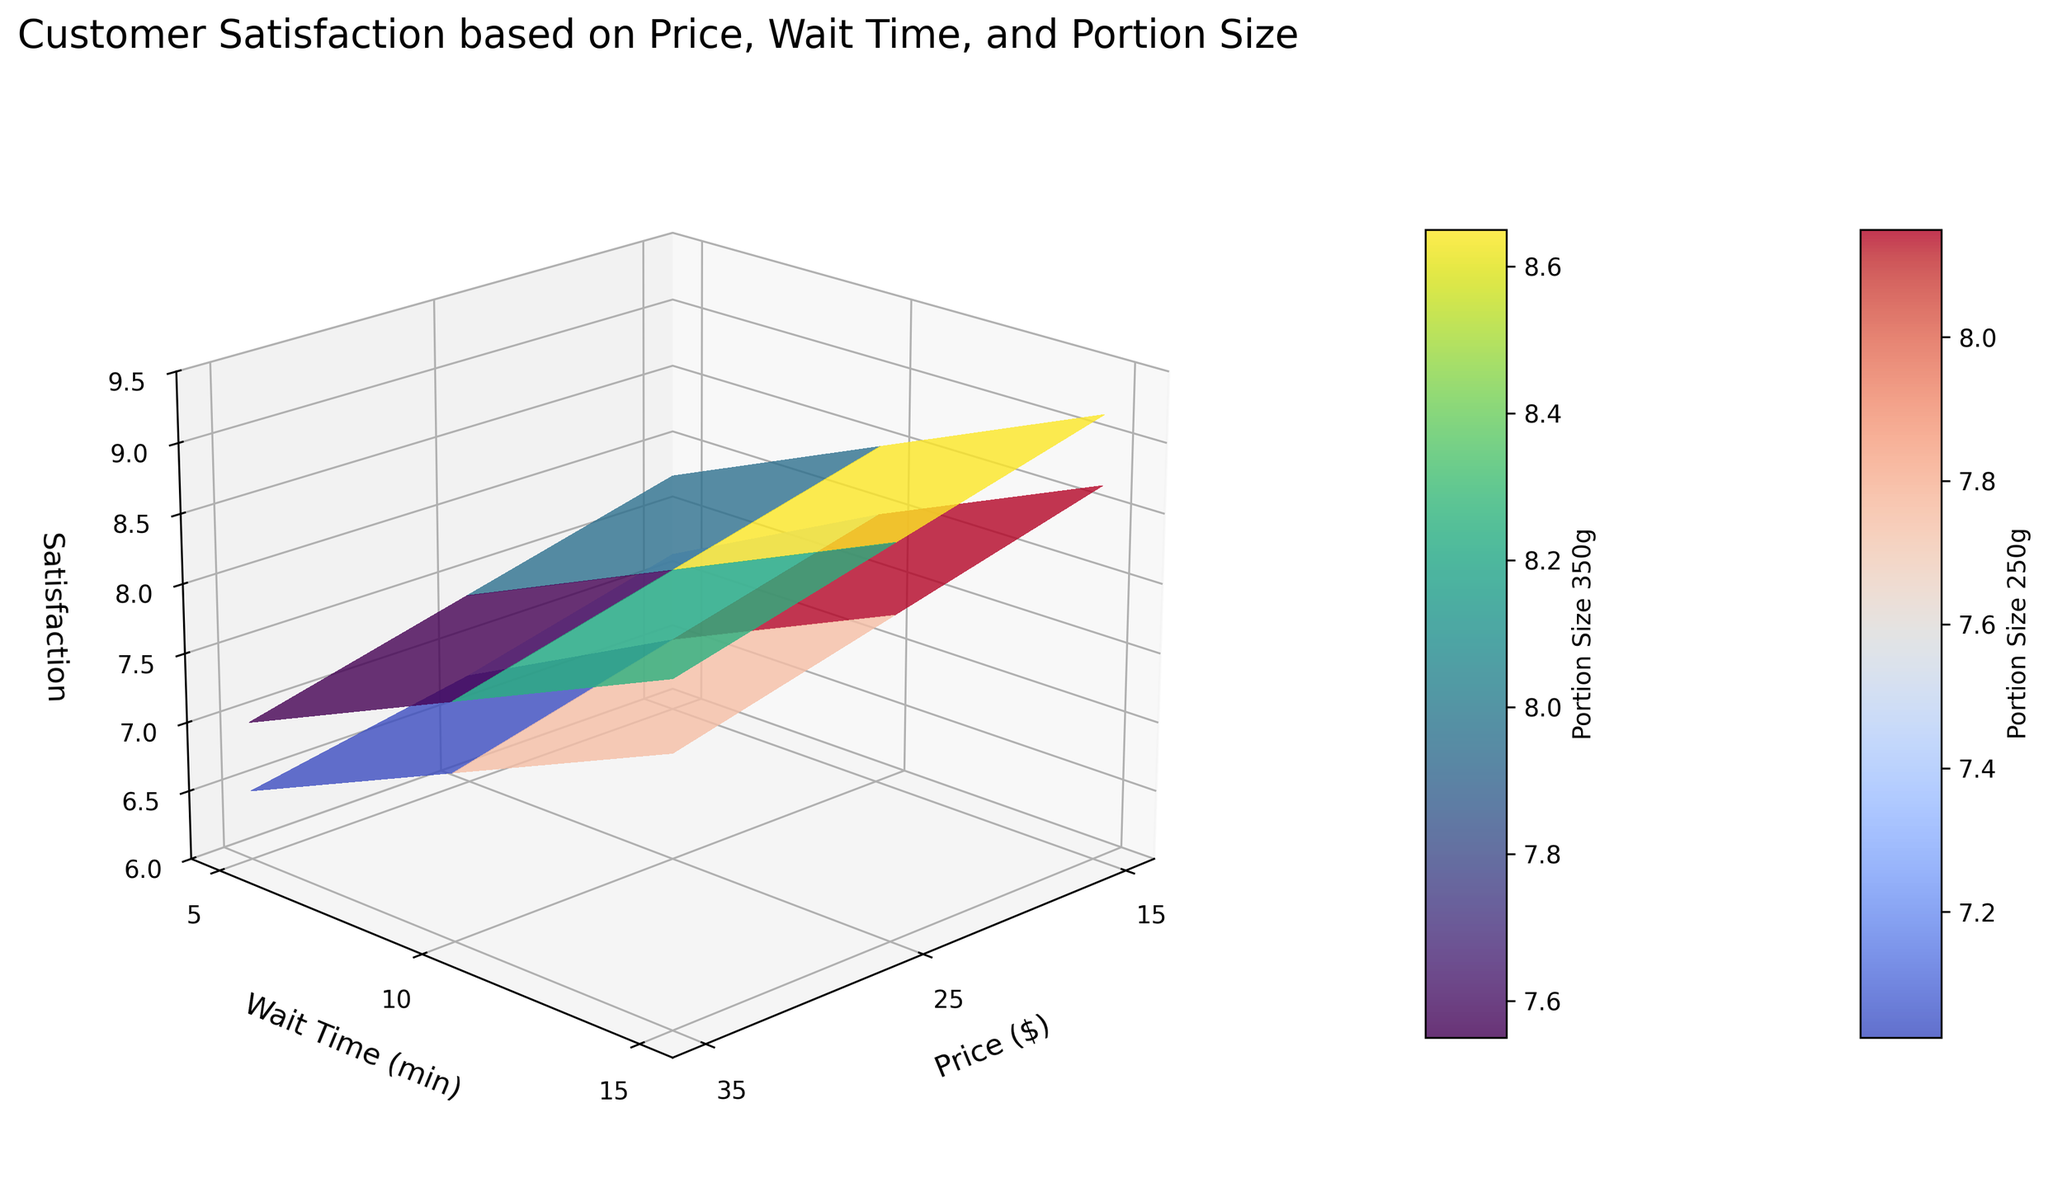What is the title of the 3D surface plot? The title is located at the top of the plot and provides insights into the context of the data represented. It typically describes what the plot is about. The title of the plot reads "Customer Satisfaction based on Price, Wait Time, and Portion Size."
Answer: Customer Satisfaction based on Price, Wait Time, and Portion Size What are the labels of the x-axis, y-axis, and z-axis? The labels can be found on their respective axes and define what each axis represents. The x-axis label is "Price ($)," the y-axis label is "Wait Time (min)," and the z-axis label is "Satisfaction."
Answer: Price ($), Wait Time (min), Satisfaction At the price of $25 and waiting time of 10 minutes, which portion size has higher satisfaction? By identifying satisfaction ratings at the price of $25 and waiting time of 10 minutes for both portion sizes (250g and 350g), we can determine which rating is higher. Referring to the figure, we see that the satisfaction for portion size 250g is around 7.6, whereas for portion size 350g it is about 8.1.
Answer: Portion size 350g How does customer satisfaction change with increasing price for a wait time of 5 minutes and portion size of 350g? To answer this, look at the surface plot for a waiting time of 5 minutes and portion size of 350g. As the price increases from 15 to 35 dollars, the satisfaction rating also increases, going from around 7.8 to 9.2.
Answer: Increases When the price is set at $35 and portion size is 350g, what is the range of satisfaction values for different wait times? We examine the section of the plot where the price is $35 and portion size is 350g. The satisfaction ratings at wait times 5, 10, and 15 minutes are 9.2, 8.8, and 8.4, respectively. Thus, the range is from 8.4 to 9.2.
Answer: 8.4 to 9.2 What can you say about the effect of wait time on satisfaction for a price of $35 and a portion size of 250g? By examining the section of the plot where the price is $35 and the portion size is 250g, we observe satisfaction ratings at wait times 5, 10, and 15 minutes. Satisfaction decreases as wait time increases: 8.7 at 5 minutes, 8.3 at 10 minutes, and 7.9 at 15 minutes.
Answer: Decreases How do satisfaction ratings for portion sizes 250g and 350g compare at a price of $15 and a wait time of 5 minutes? Inspect the corresponding satisfaction values at the price of $15 and wait time of 5 minutes. The satisfaction for a portion size of 250g is 7.2, while for a portion size of 350g it is 7.8. The comparison reveals that the 350g portion size has a higher rating.
Answer: Portion size 350g is higher Based on the plot, is customer satisfaction more sensitive to price changes or wait time changes when the portion size is 250g and price is set at $25? By examining the section of the plot for a portion size of 250g and price set at $25, we compare the changes in satisfaction for wait times 5, 10, and 15 minutes (8.0, 7.6, and 7.2) with those for prices $15, $25, and $35 (7.2, 8.0, and 8.7). Satisfaction shows a clearer trend and larger changes with varying price compared to wait time.
Answer: More sensitive to price changes 